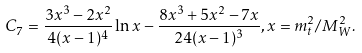Convert formula to latex. <formula><loc_0><loc_0><loc_500><loc_500>C _ { 7 } = \frac { 3 x ^ { 3 } - 2 x ^ { 2 } } { 4 ( x - 1 ) ^ { 4 } } \ln x - \frac { 8 x ^ { 3 } + 5 x ^ { 2 } - 7 x } { 2 4 ( x - 1 ) ^ { 3 } } , x = m _ { t } ^ { 2 } / M _ { W } ^ { 2 } .</formula> 